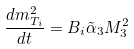<formula> <loc_0><loc_0><loc_500><loc_500>\frac { d m _ { T _ { i } } ^ { 2 } } { d t } = B _ { i } \tilde { \alpha } _ { 3 } M _ { 3 } ^ { 2 }</formula> 